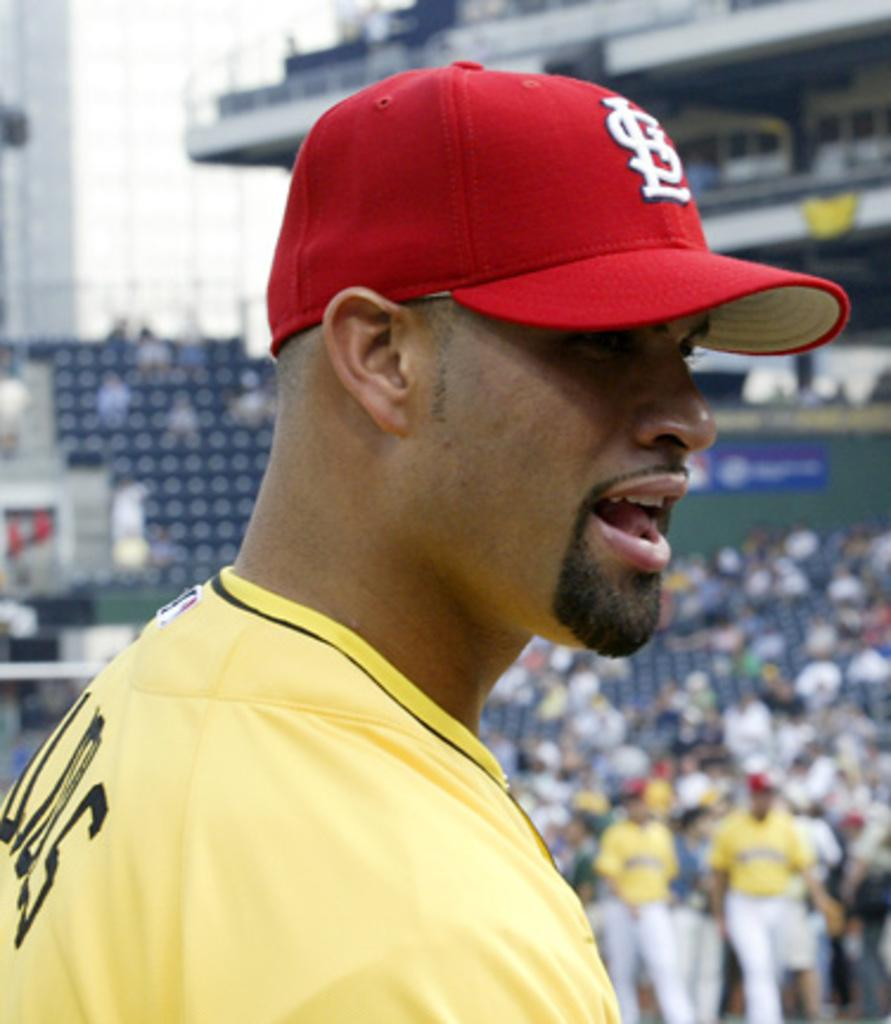Provide a one-sentence caption for the provided image. A baseball player with a hat that says STL which stands for St Louis Cardinals. 